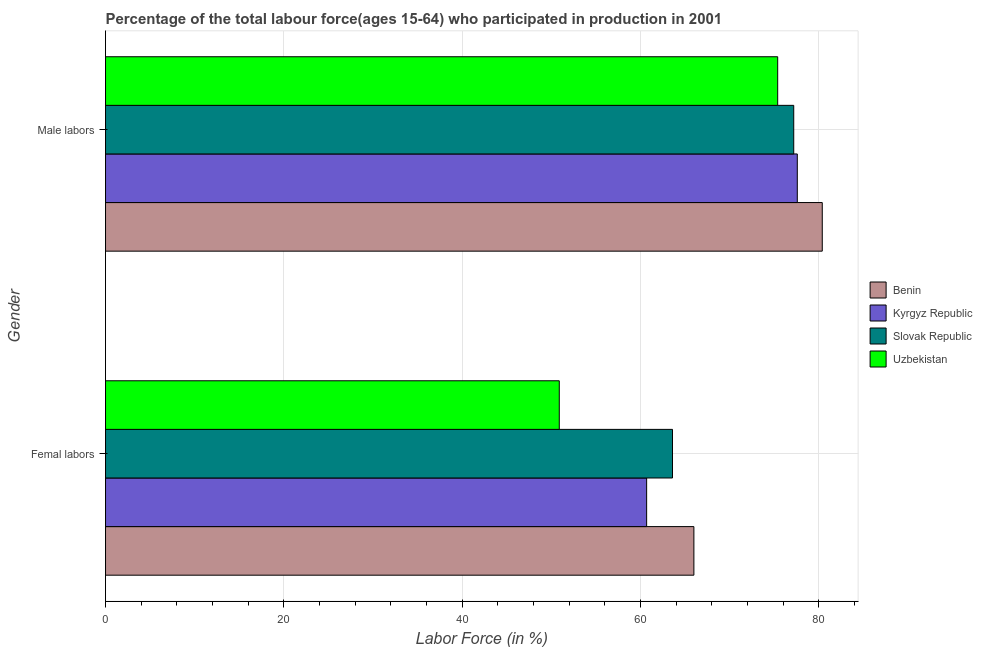How many groups of bars are there?
Provide a succinct answer. 2. Are the number of bars on each tick of the Y-axis equal?
Give a very brief answer. Yes. How many bars are there on the 2nd tick from the top?
Your response must be concise. 4. What is the label of the 1st group of bars from the top?
Give a very brief answer. Male labors. What is the percentage of male labour force in Benin?
Ensure brevity in your answer.  80.4. Across all countries, what is the maximum percentage of female labor force?
Provide a short and direct response. 66. Across all countries, what is the minimum percentage of female labor force?
Provide a succinct answer. 50.9. In which country was the percentage of male labour force maximum?
Keep it short and to the point. Benin. In which country was the percentage of male labour force minimum?
Provide a succinct answer. Uzbekistan. What is the total percentage of male labour force in the graph?
Provide a succinct answer. 310.6. What is the difference between the percentage of male labour force in Uzbekistan and that in Kyrgyz Republic?
Keep it short and to the point. -2.2. What is the difference between the percentage of male labour force in Kyrgyz Republic and the percentage of female labor force in Benin?
Your answer should be compact. 11.6. What is the average percentage of male labour force per country?
Offer a terse response. 77.65. What is the difference between the percentage of female labor force and percentage of male labour force in Kyrgyz Republic?
Keep it short and to the point. -16.9. What is the ratio of the percentage of female labor force in Slovak Republic to that in Benin?
Ensure brevity in your answer.  0.96. What does the 2nd bar from the top in Male labors represents?
Keep it short and to the point. Slovak Republic. What does the 4th bar from the bottom in Male labors represents?
Keep it short and to the point. Uzbekistan. How many bars are there?
Your answer should be compact. 8. What is the difference between two consecutive major ticks on the X-axis?
Offer a terse response. 20. Does the graph contain any zero values?
Provide a succinct answer. No. How many legend labels are there?
Give a very brief answer. 4. How are the legend labels stacked?
Make the answer very short. Vertical. What is the title of the graph?
Keep it short and to the point. Percentage of the total labour force(ages 15-64) who participated in production in 2001. What is the label or title of the X-axis?
Your answer should be compact. Labor Force (in %). What is the label or title of the Y-axis?
Offer a terse response. Gender. What is the Labor Force (in %) of Benin in Femal labors?
Offer a terse response. 66. What is the Labor Force (in %) of Kyrgyz Republic in Femal labors?
Ensure brevity in your answer.  60.7. What is the Labor Force (in %) in Slovak Republic in Femal labors?
Provide a succinct answer. 63.6. What is the Labor Force (in %) in Uzbekistan in Femal labors?
Provide a succinct answer. 50.9. What is the Labor Force (in %) in Benin in Male labors?
Ensure brevity in your answer.  80.4. What is the Labor Force (in %) of Kyrgyz Republic in Male labors?
Your answer should be very brief. 77.6. What is the Labor Force (in %) in Slovak Republic in Male labors?
Offer a very short reply. 77.2. What is the Labor Force (in %) of Uzbekistan in Male labors?
Your answer should be very brief. 75.4. Across all Gender, what is the maximum Labor Force (in %) of Benin?
Your response must be concise. 80.4. Across all Gender, what is the maximum Labor Force (in %) of Kyrgyz Republic?
Offer a very short reply. 77.6. Across all Gender, what is the maximum Labor Force (in %) in Slovak Republic?
Your answer should be compact. 77.2. Across all Gender, what is the maximum Labor Force (in %) in Uzbekistan?
Offer a terse response. 75.4. Across all Gender, what is the minimum Labor Force (in %) in Kyrgyz Republic?
Your answer should be compact. 60.7. Across all Gender, what is the minimum Labor Force (in %) of Slovak Republic?
Your answer should be very brief. 63.6. Across all Gender, what is the minimum Labor Force (in %) in Uzbekistan?
Provide a succinct answer. 50.9. What is the total Labor Force (in %) of Benin in the graph?
Your response must be concise. 146.4. What is the total Labor Force (in %) in Kyrgyz Republic in the graph?
Ensure brevity in your answer.  138.3. What is the total Labor Force (in %) of Slovak Republic in the graph?
Your answer should be compact. 140.8. What is the total Labor Force (in %) in Uzbekistan in the graph?
Offer a very short reply. 126.3. What is the difference between the Labor Force (in %) of Benin in Femal labors and that in Male labors?
Give a very brief answer. -14.4. What is the difference between the Labor Force (in %) of Kyrgyz Republic in Femal labors and that in Male labors?
Your response must be concise. -16.9. What is the difference between the Labor Force (in %) of Uzbekistan in Femal labors and that in Male labors?
Make the answer very short. -24.5. What is the difference between the Labor Force (in %) of Kyrgyz Republic in Femal labors and the Labor Force (in %) of Slovak Republic in Male labors?
Make the answer very short. -16.5. What is the difference between the Labor Force (in %) of Kyrgyz Republic in Femal labors and the Labor Force (in %) of Uzbekistan in Male labors?
Your answer should be very brief. -14.7. What is the average Labor Force (in %) in Benin per Gender?
Ensure brevity in your answer.  73.2. What is the average Labor Force (in %) in Kyrgyz Republic per Gender?
Keep it short and to the point. 69.15. What is the average Labor Force (in %) in Slovak Republic per Gender?
Your answer should be very brief. 70.4. What is the average Labor Force (in %) of Uzbekistan per Gender?
Give a very brief answer. 63.15. What is the difference between the Labor Force (in %) of Benin and Labor Force (in %) of Uzbekistan in Femal labors?
Offer a terse response. 15.1. What is the difference between the Labor Force (in %) in Kyrgyz Republic and Labor Force (in %) in Slovak Republic in Femal labors?
Your response must be concise. -2.9. What is the difference between the Labor Force (in %) in Benin and Labor Force (in %) in Kyrgyz Republic in Male labors?
Your answer should be very brief. 2.8. What is the difference between the Labor Force (in %) in Slovak Republic and Labor Force (in %) in Uzbekistan in Male labors?
Provide a short and direct response. 1.8. What is the ratio of the Labor Force (in %) in Benin in Femal labors to that in Male labors?
Your answer should be compact. 0.82. What is the ratio of the Labor Force (in %) of Kyrgyz Republic in Femal labors to that in Male labors?
Offer a terse response. 0.78. What is the ratio of the Labor Force (in %) in Slovak Republic in Femal labors to that in Male labors?
Offer a terse response. 0.82. What is the ratio of the Labor Force (in %) in Uzbekistan in Femal labors to that in Male labors?
Your answer should be compact. 0.68. What is the difference between the highest and the second highest Labor Force (in %) in Kyrgyz Republic?
Provide a short and direct response. 16.9. What is the difference between the highest and the second highest Labor Force (in %) of Slovak Republic?
Provide a succinct answer. 13.6. What is the difference between the highest and the second highest Labor Force (in %) of Uzbekistan?
Provide a short and direct response. 24.5. What is the difference between the highest and the lowest Labor Force (in %) in Benin?
Give a very brief answer. 14.4. What is the difference between the highest and the lowest Labor Force (in %) in Slovak Republic?
Your answer should be compact. 13.6. What is the difference between the highest and the lowest Labor Force (in %) of Uzbekistan?
Your response must be concise. 24.5. 